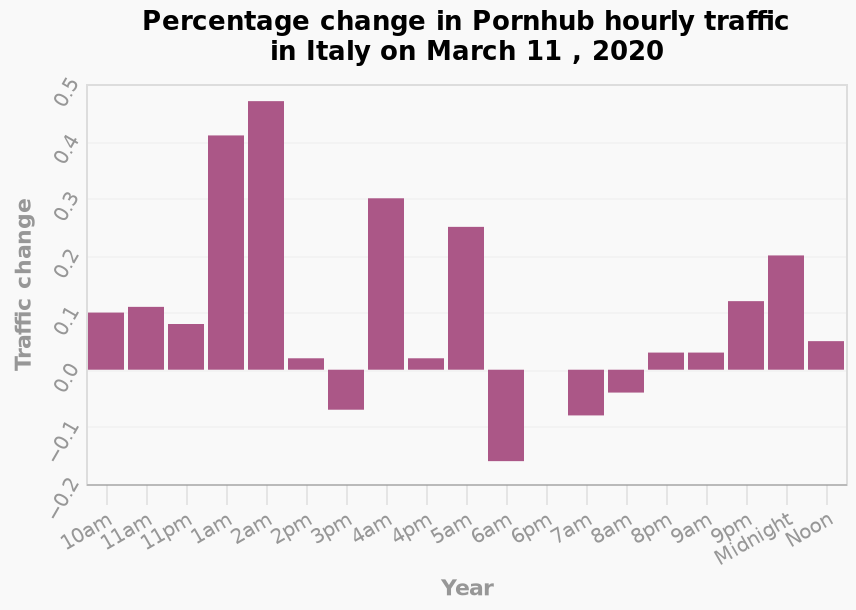<image>
What is the name of the bar diagram?  The bar diagram is named "Percentage change in Pornhub hourly traffic in Italy on March 11, 2020." Describe the following image in detail This is a bar diagram named Percentage change in Pornhub hourly traffic in Italy on March 11 , 2020. On the x-axis, Year is drawn on a categorical scale starting at 10am and ending at Noon. Along the y-axis, Traffic change is shown on a categorical scale starting at −0.2 and ending at 0.5. 